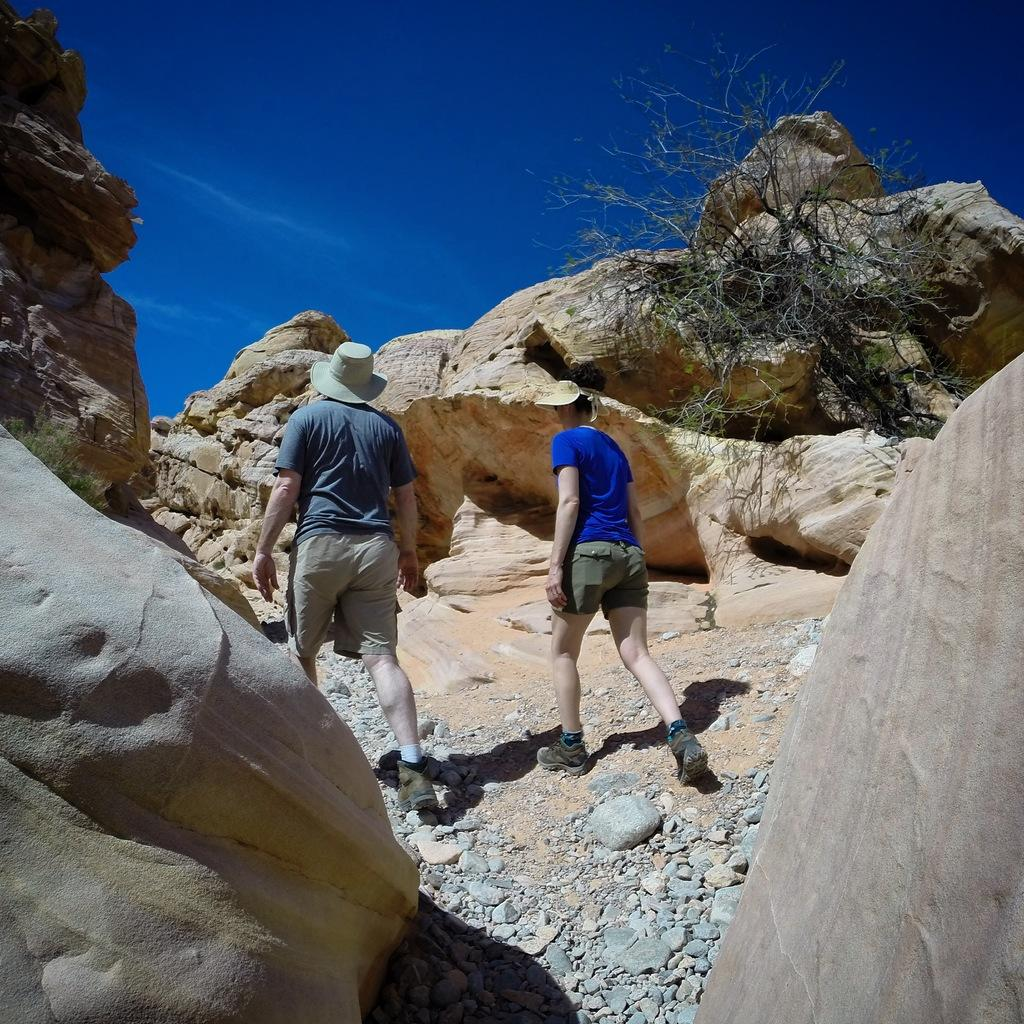How many people are walking in the image? There are two persons walking in the image. What type of terrain can be seen in the image? There are stones, hills, and trees visible in the image. What is visible at the top of the image? Clouds and the sky are visible at the top of the image. Where is the bucket located in the image? There is no bucket present in the image. What type of kitten can be seen playing with the base in the image? There is no kitten or base present in the image. 